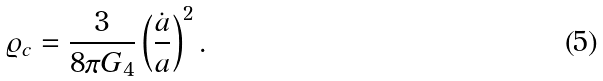Convert formula to latex. <formula><loc_0><loc_0><loc_500><loc_500>\varrho _ { c } = { \frac { 3 } { 8 \pi G _ { 4 } } } \left ( { \frac { \dot { a } } { a } } \right ) ^ { 2 } .</formula> 